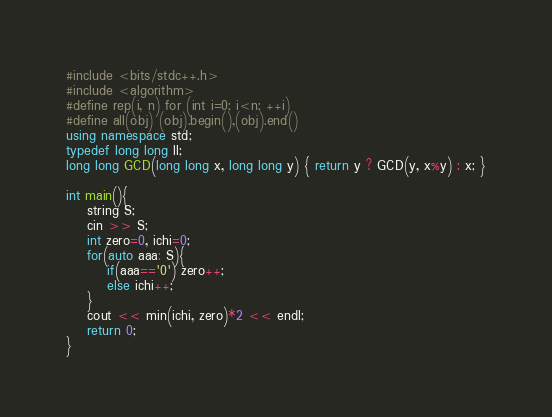Convert code to text. <code><loc_0><loc_0><loc_500><loc_500><_C++_>#include <bits/stdc++.h>
#include <algorithm>
#define rep(i, n) for (int i=0; i<n; ++i)
#define all(obj) (obj).begin(),(obj).end()
using namespace std;
typedef long long ll;
long long GCD(long long x, long long y) { return y ? GCD(y, x%y) : x; }

int main(){
    string S;
    cin >> S;
    int zero=0, ichi=0;
    for(auto aaa: S){
        if(aaa=='0') zero++;
        else ichi++;
    }
    cout << min(ichi, zero)*2 << endl;
    return 0;
}
</code> 